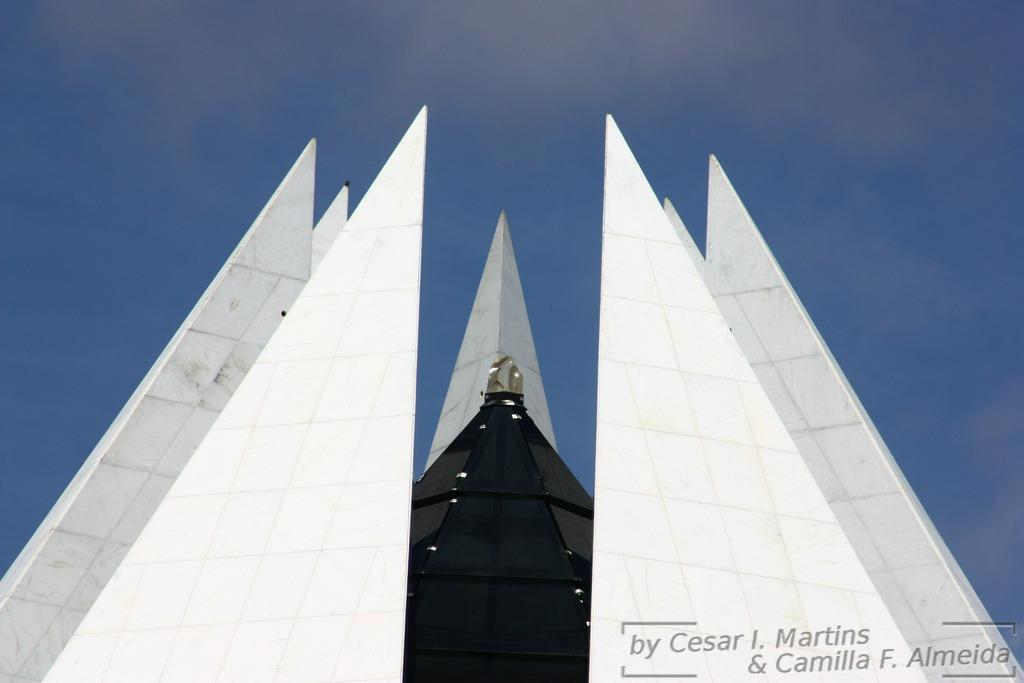What type of subject is depicted in the image? The image appears to depict an architectural structure. What can be seen in the background of the image? The sky is visible at the top of the image. Is there any additional information or marking present in the image? Yes, there is a watermark at the bottom of the image. How many rings are visible on the slave's fingers in the image? There is no slave or rings present in the image; it depicts an architectural structure. 